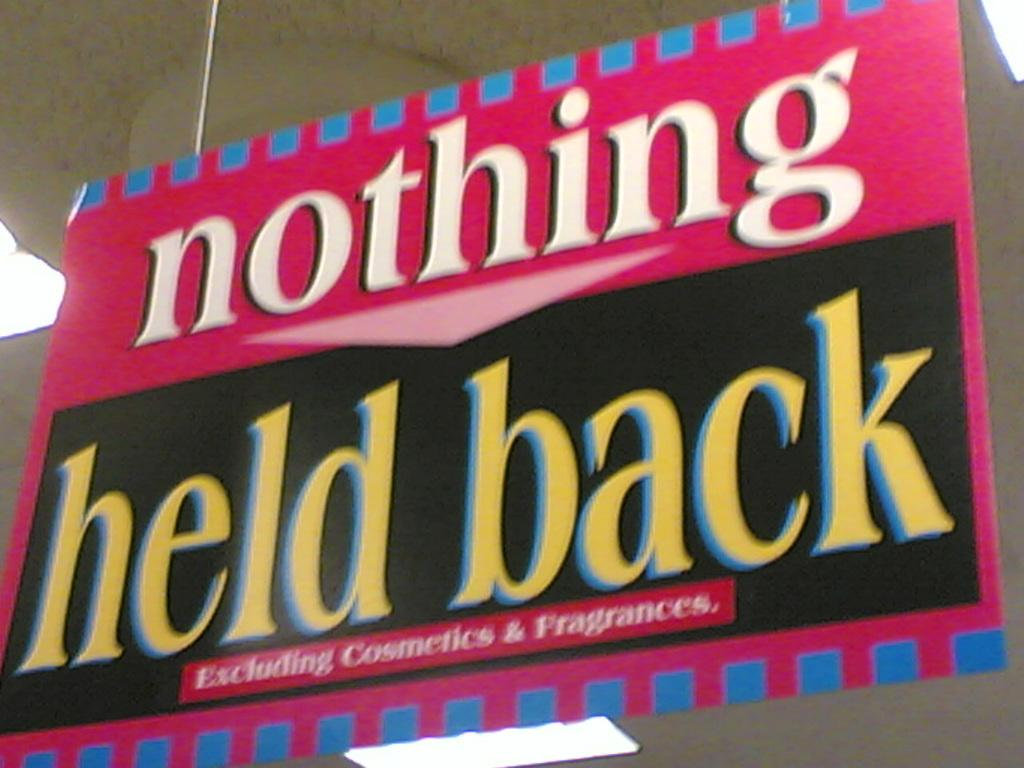<image>
Summarize the visual content of the image. A large pink and black sign saying "nothing held back" 